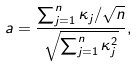<formula> <loc_0><loc_0><loc_500><loc_500>a = \frac { \sum _ { j = 1 } ^ { n } \kappa _ { j } / \sqrt { n } } { \sqrt { \sum _ { j = 1 } ^ { n } \kappa _ { j } ^ { 2 } } } ,</formula> 